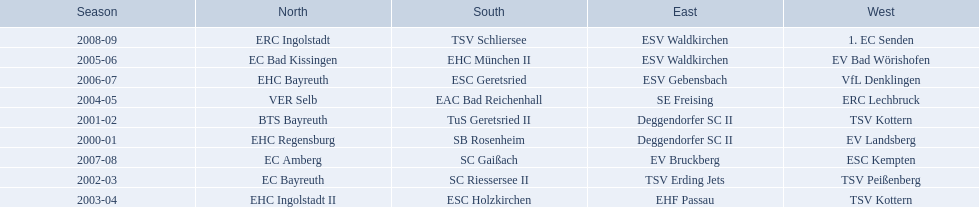Which teams have won in the bavarian ice hockey leagues between 2000 and 2009? EHC Regensburg, SB Rosenheim, Deggendorfer SC II, EV Landsberg, BTS Bayreuth, TuS Geretsried II, TSV Kottern, EC Bayreuth, SC Riessersee II, TSV Erding Jets, TSV Peißenberg, EHC Ingolstadt II, ESC Holzkirchen, EHF Passau, TSV Kottern, VER Selb, EAC Bad Reichenhall, SE Freising, ERC Lechbruck, EC Bad Kissingen, EHC München II, ESV Waldkirchen, EV Bad Wörishofen, EHC Bayreuth, ESC Geretsried, ESV Gebensbach, VfL Denklingen, EC Amberg, SC Gaißach, EV Bruckberg, ESC Kempten, ERC Ingolstadt, TSV Schliersee, ESV Waldkirchen, 1. EC Senden. Which of these winning teams have won the north? EHC Regensburg, BTS Bayreuth, EC Bayreuth, EHC Ingolstadt II, VER Selb, EC Bad Kissingen, EHC Bayreuth, EC Amberg, ERC Ingolstadt. Which of the teams that won the north won in the 2000/2001 season? EHC Regensburg. 